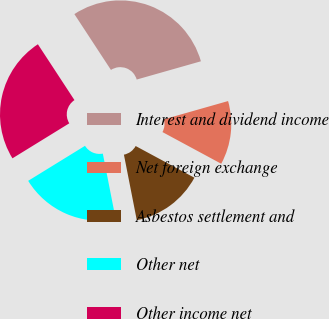Convert chart. <chart><loc_0><loc_0><loc_500><loc_500><pie_chart><fcel>Interest and dividend income<fcel>Net foreign exchange<fcel>Asbestos settlement and<fcel>Other net<fcel>Other income net<nl><fcel>29.82%<fcel>12.28%<fcel>14.04%<fcel>19.3%<fcel>24.56%<nl></chart> 